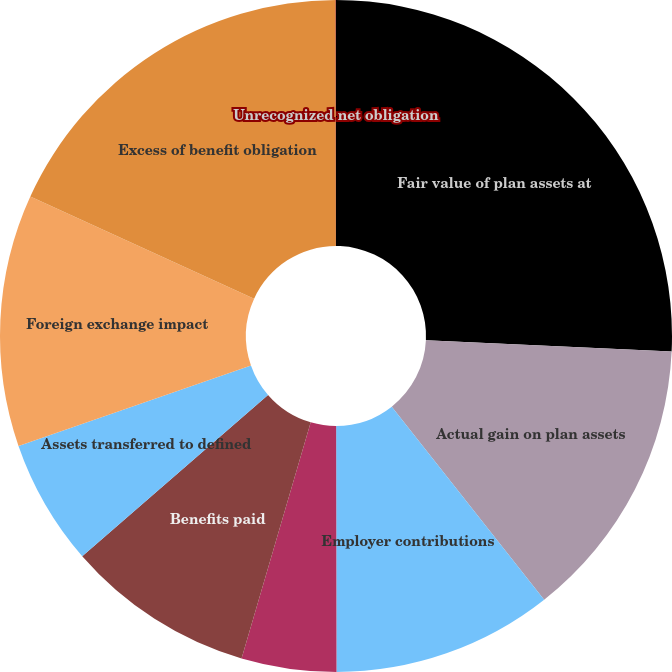Convert chart to OTSL. <chart><loc_0><loc_0><loc_500><loc_500><pie_chart><fcel>Fair value of plan assets at<fcel>Actual gain on plan assets<fcel>Employer contributions<fcel>Employee contributions<fcel>Benefits paid<fcel>Assets transferred to defined<fcel>Foreign exchange impact<fcel>Excess of benefit obligation<fcel>Unrecognized net obligation<nl><fcel>25.74%<fcel>13.63%<fcel>10.61%<fcel>4.56%<fcel>9.09%<fcel>6.07%<fcel>12.12%<fcel>18.17%<fcel>0.02%<nl></chart> 